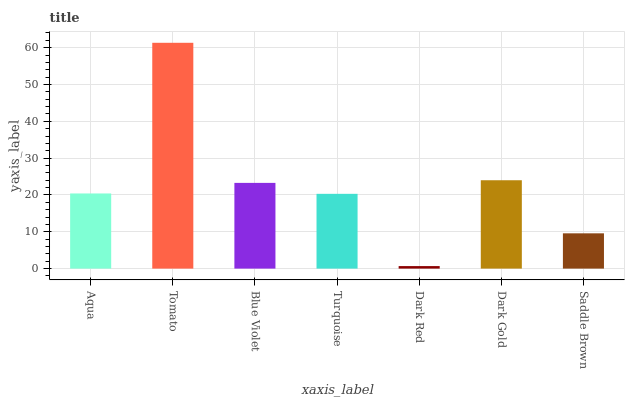Is Dark Red the minimum?
Answer yes or no. Yes. Is Tomato the maximum?
Answer yes or no. Yes. Is Blue Violet the minimum?
Answer yes or no. No. Is Blue Violet the maximum?
Answer yes or no. No. Is Tomato greater than Blue Violet?
Answer yes or no. Yes. Is Blue Violet less than Tomato?
Answer yes or no. Yes. Is Blue Violet greater than Tomato?
Answer yes or no. No. Is Tomato less than Blue Violet?
Answer yes or no. No. Is Aqua the high median?
Answer yes or no. Yes. Is Aqua the low median?
Answer yes or no. Yes. Is Saddle Brown the high median?
Answer yes or no. No. Is Tomato the low median?
Answer yes or no. No. 